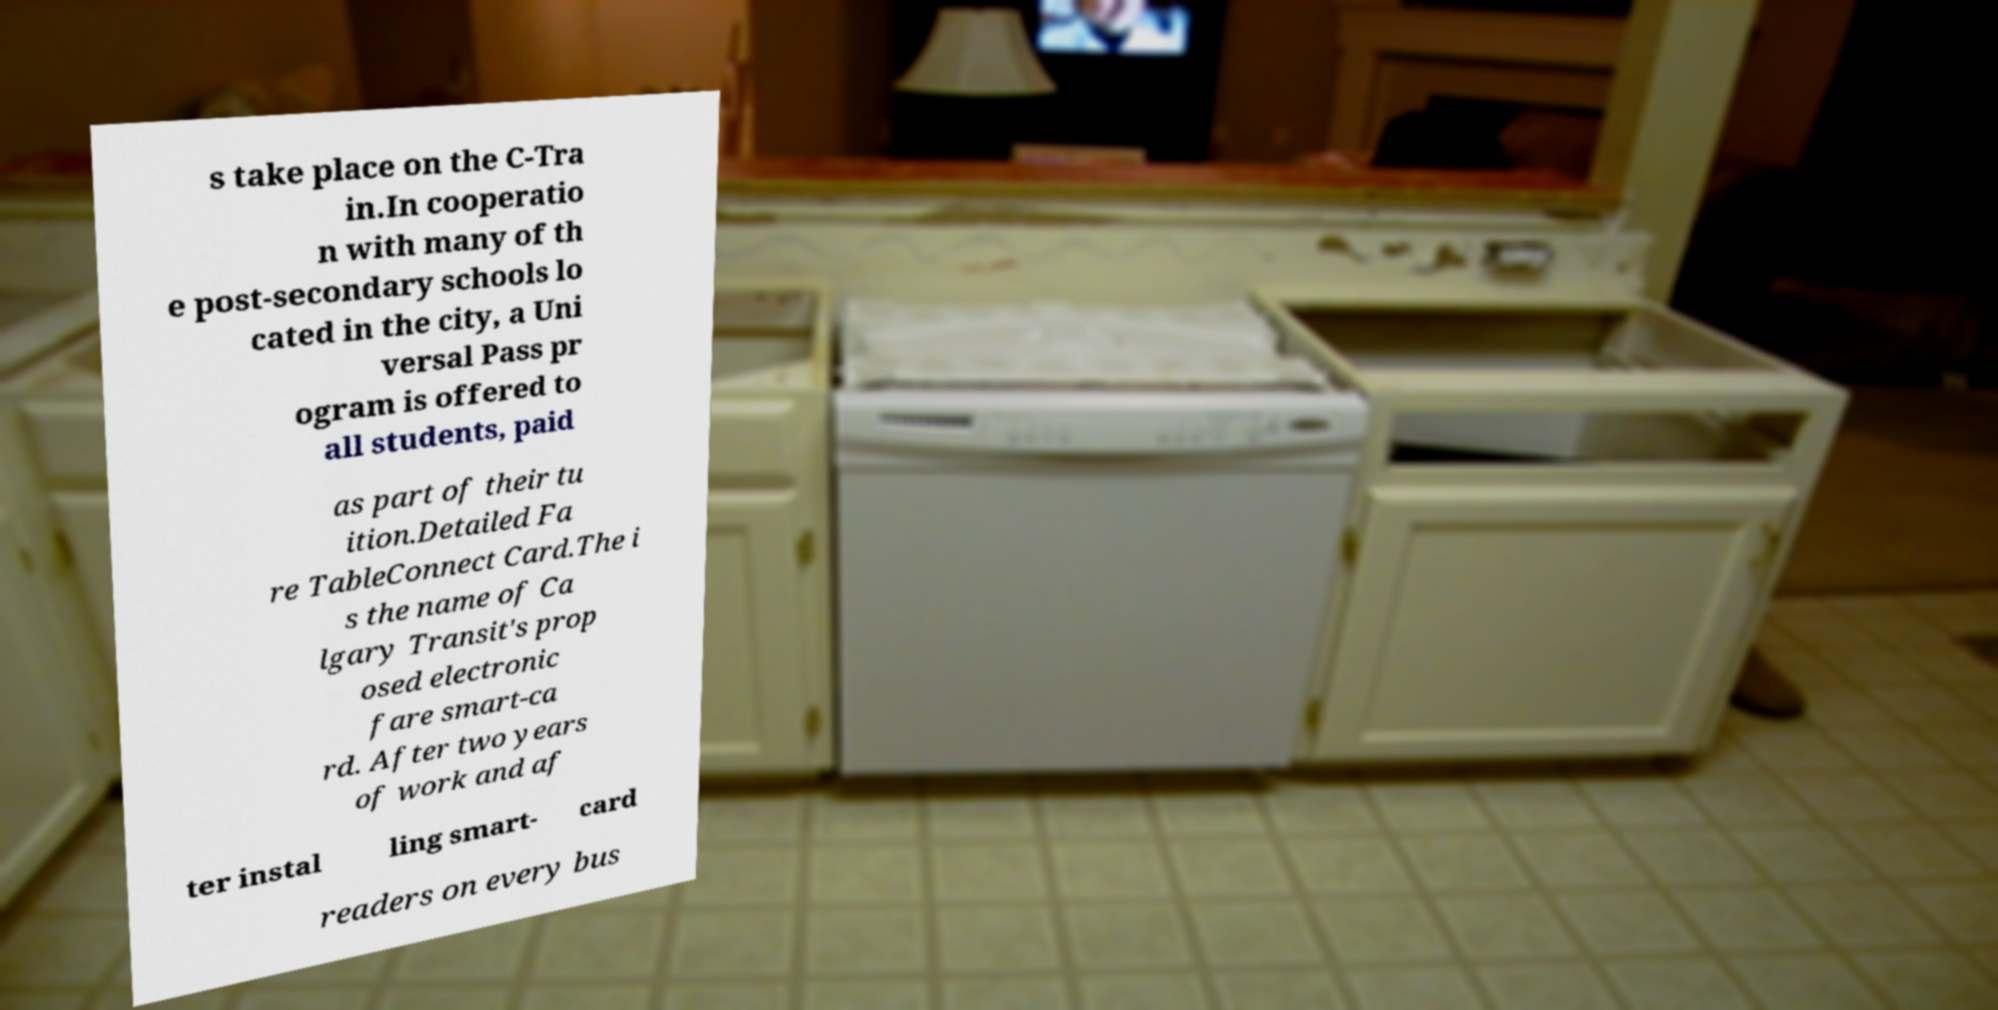Can you accurately transcribe the text from the provided image for me? s take place on the C-Tra in.In cooperatio n with many of th e post-secondary schools lo cated in the city, a Uni versal Pass pr ogram is offered to all students, paid as part of their tu ition.Detailed Fa re TableConnect Card.The i s the name of Ca lgary Transit's prop osed electronic fare smart-ca rd. After two years of work and af ter instal ling smart- card readers on every bus 